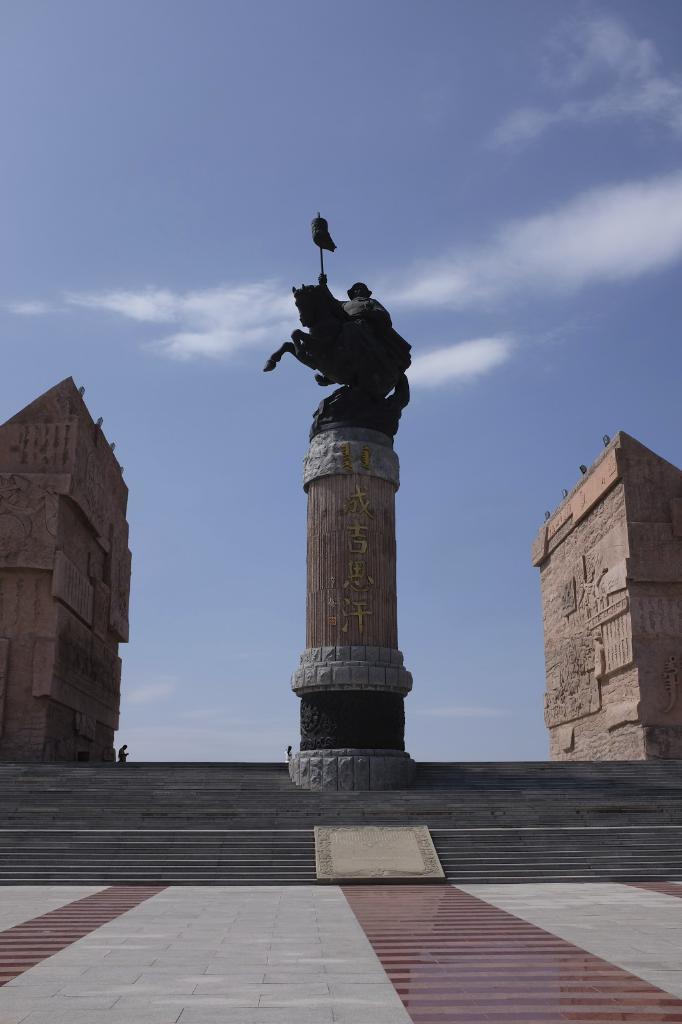In one or two sentences, can you explain what this image depicts? There is a statue of a man and a horse on a pillar. There are steps. On the sides there are buildings. In the background there is sky with cloud. 